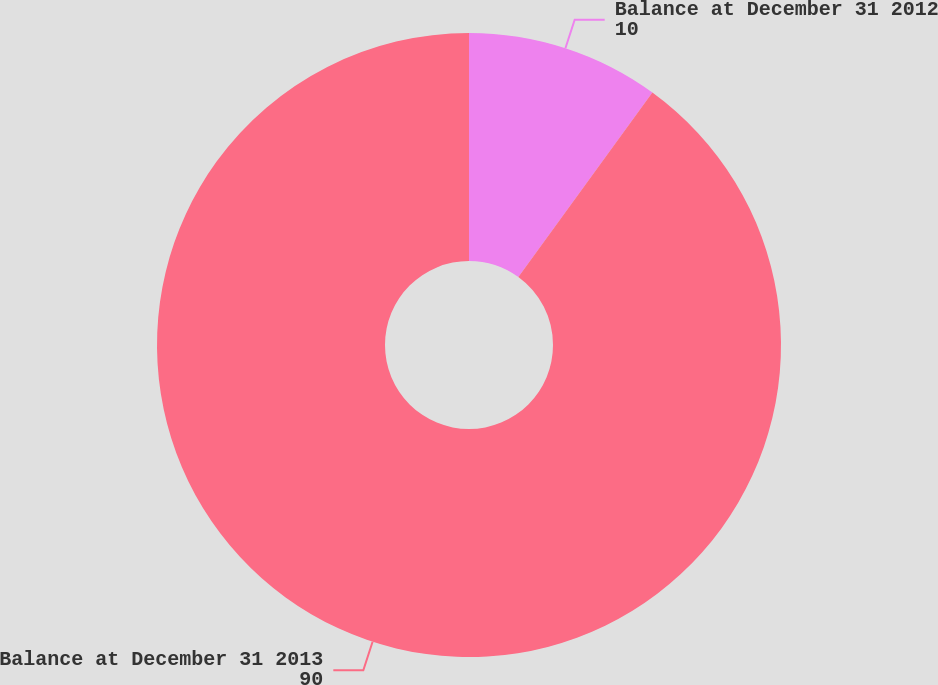Convert chart to OTSL. <chart><loc_0><loc_0><loc_500><loc_500><pie_chart><fcel>Balance at December 31 2012<fcel>Balance at December 31 2013<nl><fcel>10.0%<fcel>90.0%<nl></chart> 